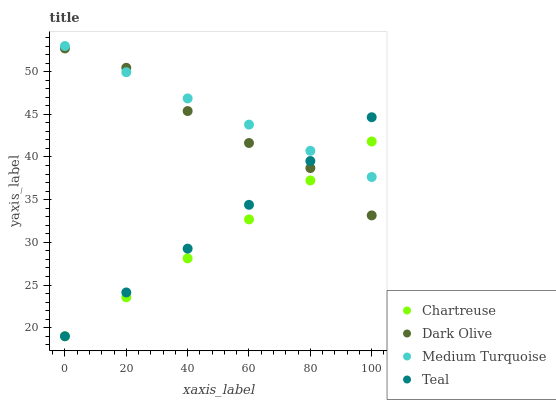Does Chartreuse have the minimum area under the curve?
Answer yes or no. Yes. Does Medium Turquoise have the maximum area under the curve?
Answer yes or no. Yes. Does Dark Olive have the minimum area under the curve?
Answer yes or no. No. Does Dark Olive have the maximum area under the curve?
Answer yes or no. No. Is Chartreuse the smoothest?
Answer yes or no. Yes. Is Dark Olive the roughest?
Answer yes or no. Yes. Is Dark Olive the smoothest?
Answer yes or no. No. Is Teal the roughest?
Answer yes or no. No. Does Chartreuse have the lowest value?
Answer yes or no. Yes. Does Dark Olive have the lowest value?
Answer yes or no. No. Does Medium Turquoise have the highest value?
Answer yes or no. Yes. Does Dark Olive have the highest value?
Answer yes or no. No. Does Teal intersect Medium Turquoise?
Answer yes or no. Yes. Is Teal less than Medium Turquoise?
Answer yes or no. No. Is Teal greater than Medium Turquoise?
Answer yes or no. No. 